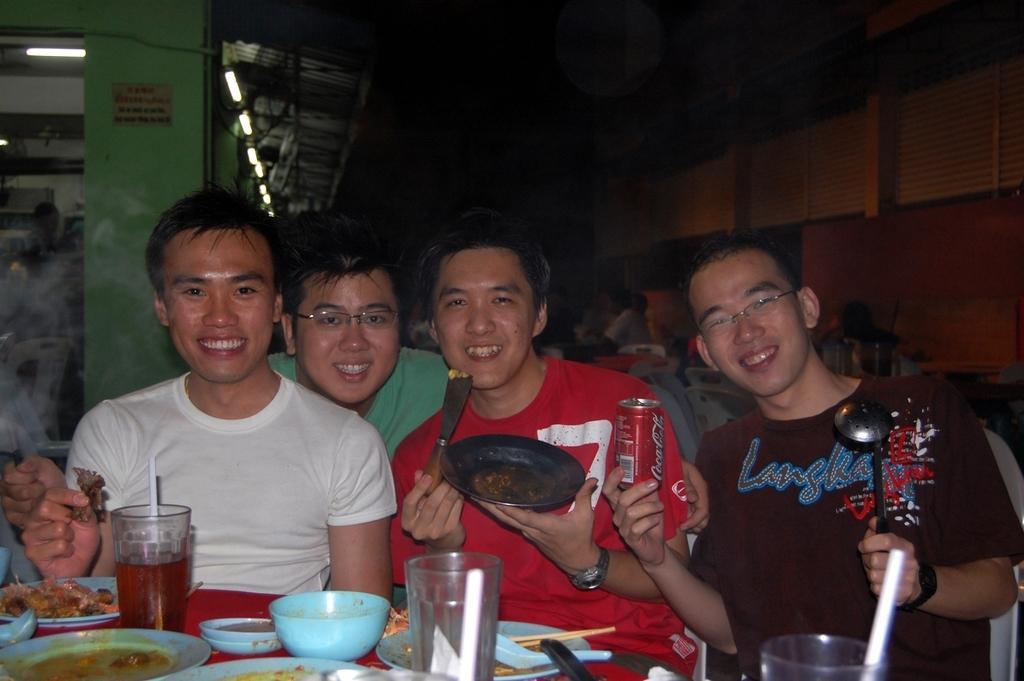Can you describe this image briefly? In this image I can see few men are sitting. Here on this table I can see number of plates and glasses. I can also see smile on their faces. 